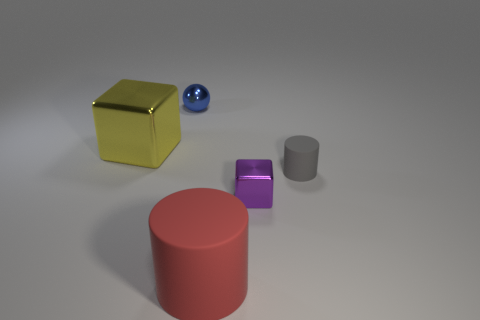How could these objects be used in a mathematical lesson? These objects could be useful in a mathematical lesson to teach about three-dimensional shapes and their properties, such as volume and surface area. Students could learn to identify and categorize geometric shapes like spheres, cubes, cylinders, and rectangular prisms. They could also learn about the concepts of symmetry, and how to calculate the volumes for each shape. Additionally, the varying sizes of the objects could be used to discuss scale and proportions. 